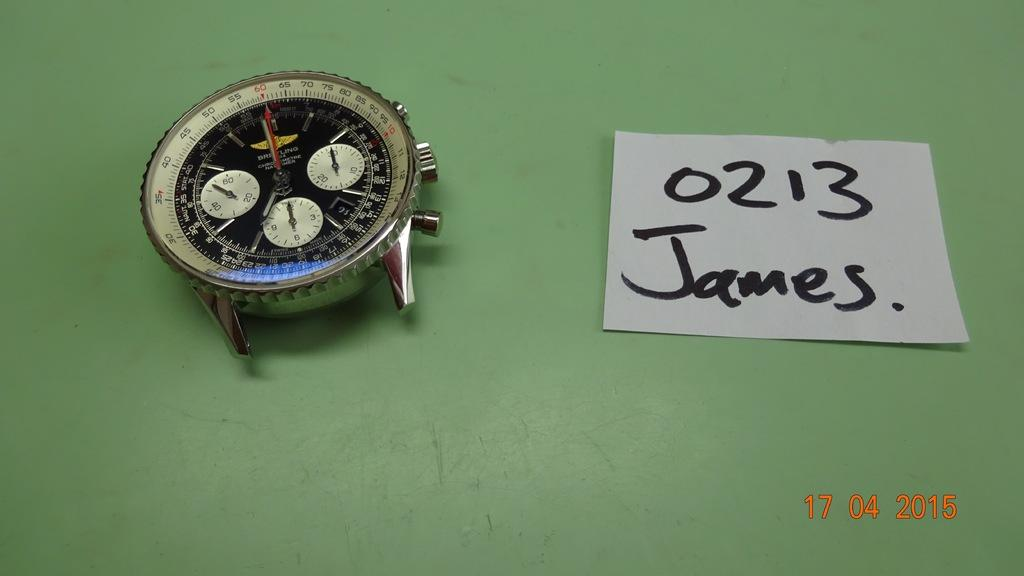<image>
Describe the image concisely. Face of a watch next to a piece of paper which says 0213 James. 